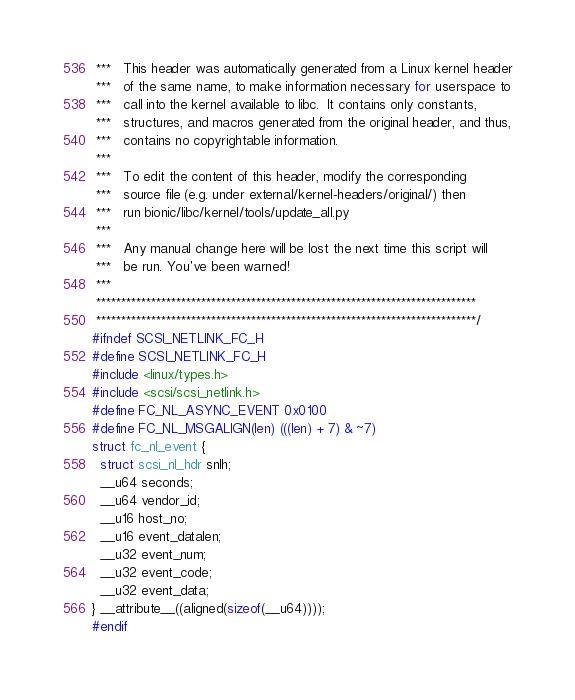<code> <loc_0><loc_0><loc_500><loc_500><_C_> ***   This header was automatically generated from a Linux kernel header
 ***   of the same name, to make information necessary for userspace to
 ***   call into the kernel available to libc.  It contains only constants,
 ***   structures, and macros generated from the original header, and thus,
 ***   contains no copyrightable information.
 ***
 ***   To edit the content of this header, modify the corresponding
 ***   source file (e.g. under external/kernel-headers/original/) then
 ***   run bionic/libc/kernel/tools/update_all.py
 ***
 ***   Any manual change here will be lost the next time this script will
 ***   be run. You've been warned!
 ***
 ****************************************************************************
 ****************************************************************************/
#ifndef SCSI_NETLINK_FC_H
#define SCSI_NETLINK_FC_H
#include <linux/types.h>
#include <scsi/scsi_netlink.h>
#define FC_NL_ASYNC_EVENT 0x0100
#define FC_NL_MSGALIGN(len) (((len) + 7) & ~7)
struct fc_nl_event {
  struct scsi_nl_hdr snlh;
  __u64 seconds;
  __u64 vendor_id;
  __u16 host_no;
  __u16 event_datalen;
  __u32 event_num;
  __u32 event_code;
  __u32 event_data;
} __attribute__((aligned(sizeof(__u64))));
#endif
</code> 